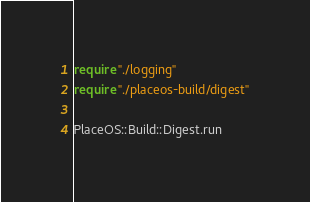Convert code to text. <code><loc_0><loc_0><loc_500><loc_500><_Crystal_>require "./logging"
require "./placeos-build/digest"

PlaceOS::Build::Digest.run
</code> 